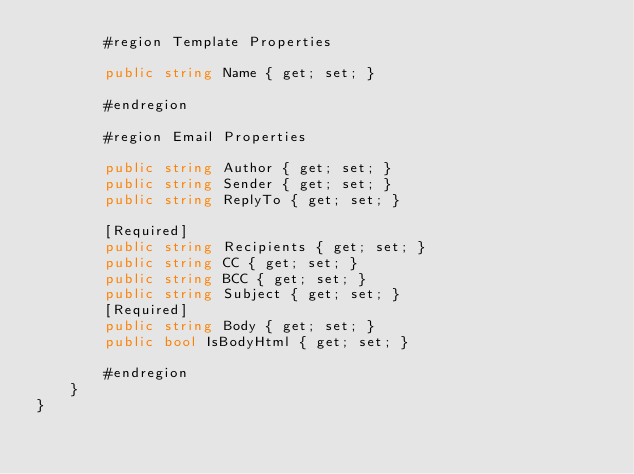<code> <loc_0><loc_0><loc_500><loc_500><_C#_>        #region Template Properties

        public string Name { get; set; }

        #endregion

        #region Email Properties

        public string Author { get; set; }
        public string Sender { get; set; }
        public string ReplyTo { get; set; }

        [Required]
        public string Recipients { get; set; }
        public string CC { get; set; }
        public string BCC { get; set; }
        public string Subject { get; set; }
        [Required]
        public string Body { get; set; }
        public bool IsBodyHtml { get; set; }

        #endregion
    }
}
</code> 